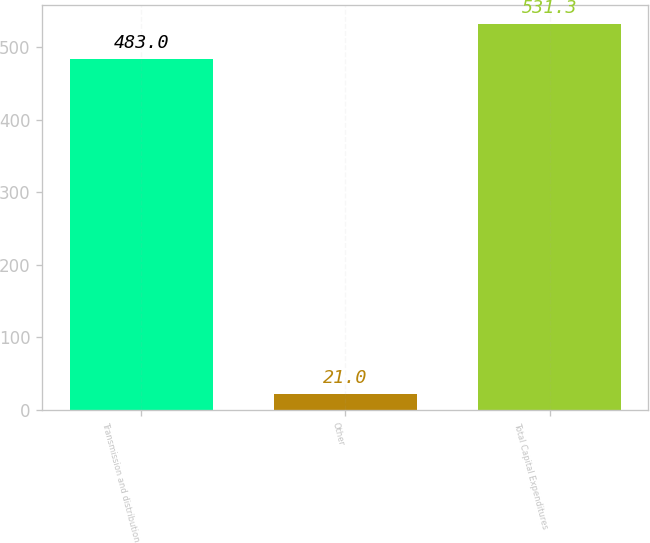<chart> <loc_0><loc_0><loc_500><loc_500><bar_chart><fcel>Transmission and distribution<fcel>Other<fcel>Total Capital Expenditures<nl><fcel>483<fcel>21<fcel>531.3<nl></chart> 